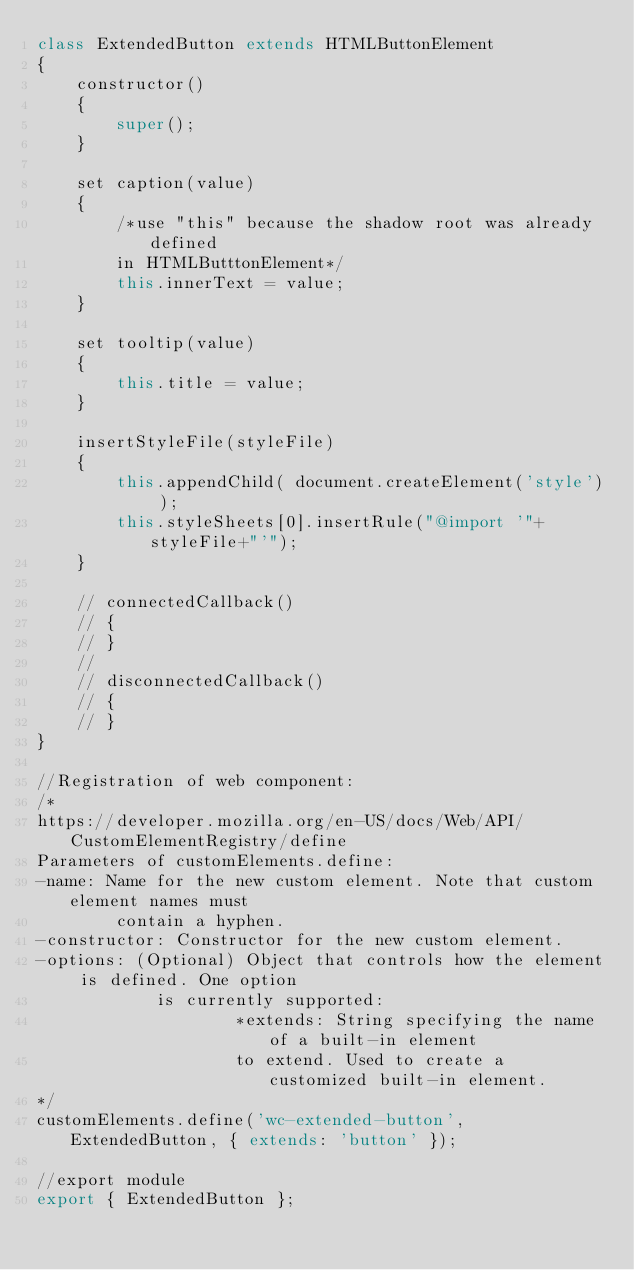Convert code to text. <code><loc_0><loc_0><loc_500><loc_500><_JavaScript_>class ExtendedButton extends HTMLButtonElement
{
    constructor()
    {
        super();
    }

    set caption(value)
    {
        /*use "this" because the shadow root was already defined
        in HTMLButttonElement*/
        this.innerText = value;
    }

    set tooltip(value)
    {
        this.title = value;
    }

    insertStyleFile(styleFile)
    {
        this.appendChild( document.createElement('style') );
        this.styleSheets[0].insertRule("@import '"+styleFile+"'");
    }

    // connectedCallback()
    // {
    // }
    //
    // disconnectedCallback()
    // {
    // }
}

//Registration of web component:
/*
https://developer.mozilla.org/en-US/docs/Web/API/CustomElementRegistry/define
Parameters of customElements.define:
-name: Name for the new custom element. Note that custom element names must
        contain a hyphen.
-constructor: Constructor for the new custom element.
-options: (Optional) Object that controls how the element is defined. One option
            is currently supported:
                    *extends: String specifying the name of a built-in element
                    to extend. Used to create a customized built-in element.
*/
customElements.define('wc-extended-button', ExtendedButton, { extends: 'button' });

//export module
export { ExtendedButton };
</code> 